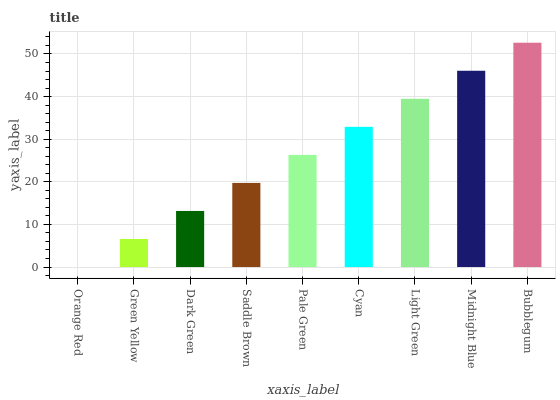Is Orange Red the minimum?
Answer yes or no. Yes. Is Bubblegum the maximum?
Answer yes or no. Yes. Is Green Yellow the minimum?
Answer yes or no. No. Is Green Yellow the maximum?
Answer yes or no. No. Is Green Yellow greater than Orange Red?
Answer yes or no. Yes. Is Orange Red less than Green Yellow?
Answer yes or no. Yes. Is Orange Red greater than Green Yellow?
Answer yes or no. No. Is Green Yellow less than Orange Red?
Answer yes or no. No. Is Pale Green the high median?
Answer yes or no. Yes. Is Pale Green the low median?
Answer yes or no. Yes. Is Saddle Brown the high median?
Answer yes or no. No. Is Cyan the low median?
Answer yes or no. No. 